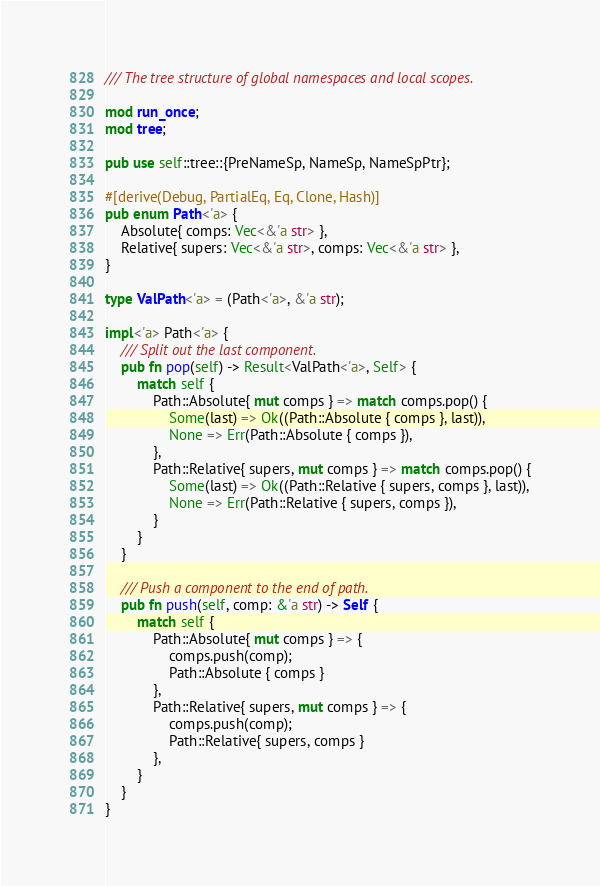Convert code to text. <code><loc_0><loc_0><loc_500><loc_500><_Rust_>/// The tree structure of global namespaces and local scopes.

mod run_once;
mod tree;

pub use self::tree::{PreNameSp, NameSp, NameSpPtr};

#[derive(Debug, PartialEq, Eq, Clone, Hash)]
pub enum Path<'a> {
    Absolute{ comps: Vec<&'a str> },
    Relative{ supers: Vec<&'a str>, comps: Vec<&'a str> },
}

type ValPath<'a> = (Path<'a>, &'a str);

impl<'a> Path<'a> {
    /// Split out the last component.
    pub fn pop(self) -> Result<ValPath<'a>, Self> {
        match self {
            Path::Absolute{ mut comps } => match comps.pop() {
                Some(last) => Ok((Path::Absolute { comps }, last)),
                None => Err(Path::Absolute { comps }),
            },
            Path::Relative{ supers, mut comps } => match comps.pop() {
                Some(last) => Ok((Path::Relative { supers, comps }, last)),
                None => Err(Path::Relative { supers, comps }),
            }
        }
    }

    /// Push a component to the end of path.
    pub fn push(self, comp: &'a str) -> Self {
        match self {
            Path::Absolute{ mut comps } => {
                comps.push(comp);
                Path::Absolute { comps }
            },
            Path::Relative{ supers, mut comps } => {
                comps.push(comp);
                Path::Relative{ supers, comps }
            },
        }
    }
}
</code> 